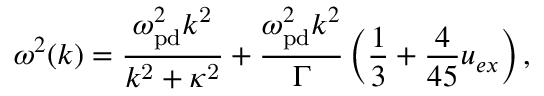<formula> <loc_0><loc_0><loc_500><loc_500>\omega ^ { 2 } ( k ) = \frac { \omega _ { p d } ^ { 2 } k ^ { 2 } } { k ^ { 2 } + \kappa ^ { 2 } } + \frac { \omega _ { p d } ^ { 2 } k ^ { 2 } } { \Gamma } \left ( \frac { 1 } { 3 } + \frac { 4 } { 4 5 } u _ { e x } \right ) ,</formula> 